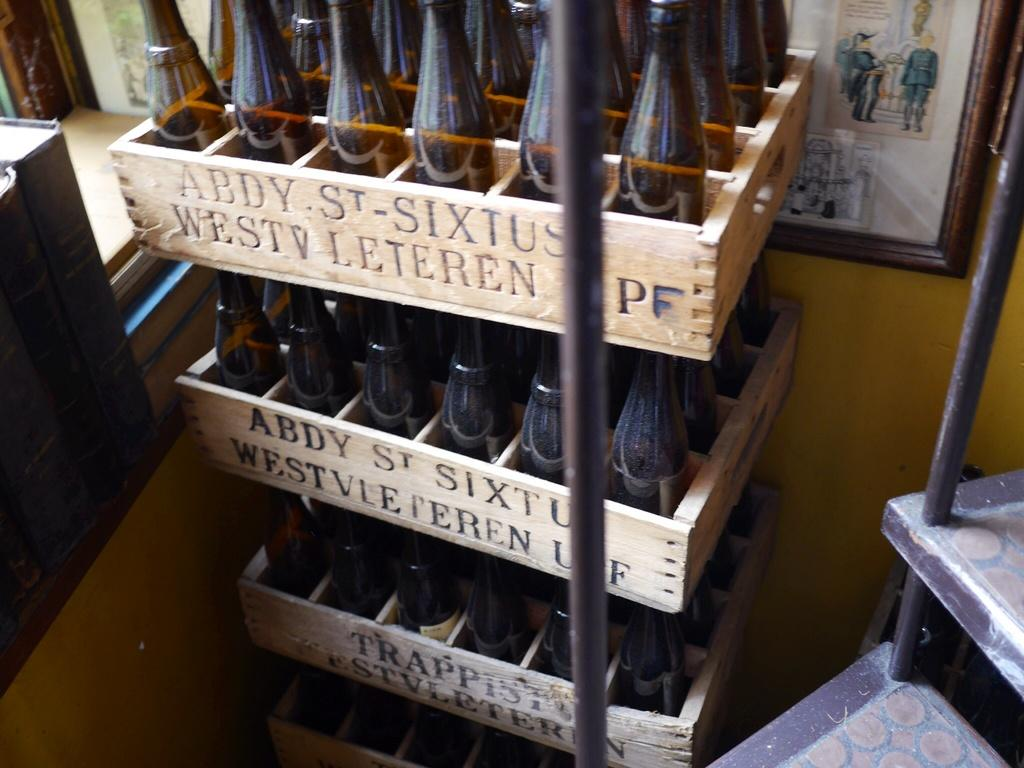<image>
Share a concise interpretation of the image provided. Many bottles sit in a crate that says abdy st. sixtus on it. 